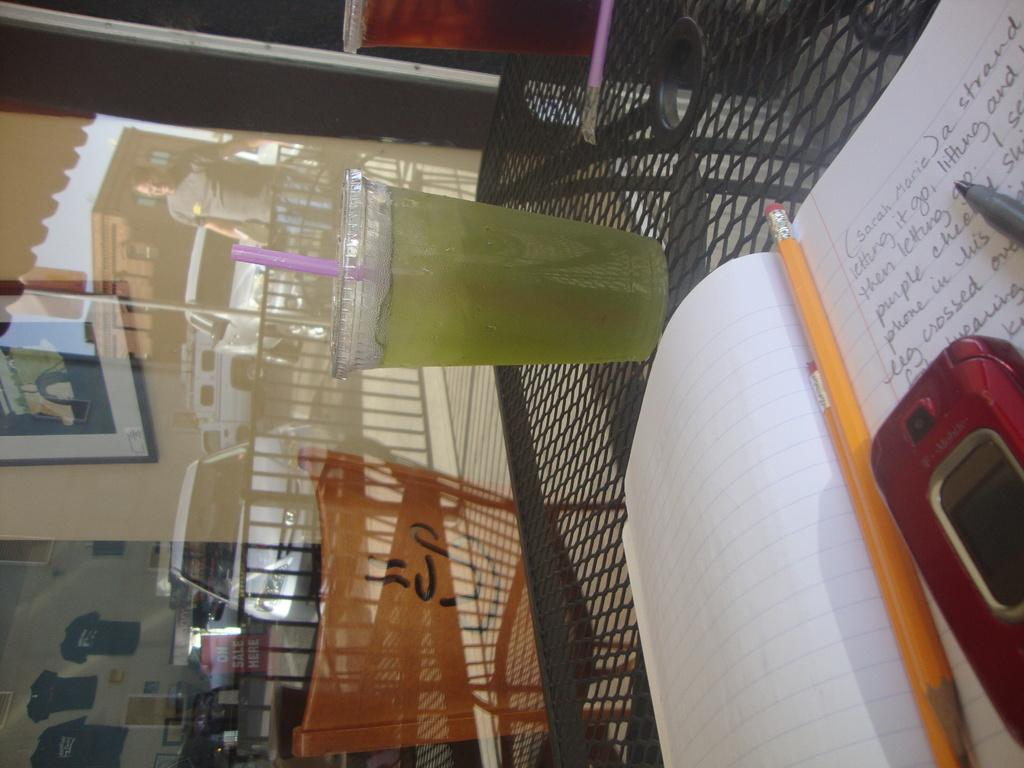<image>
Provide a brief description of the given image. A red T-mobile cell phone, a pencil and a pen rest on top of a notebook. 